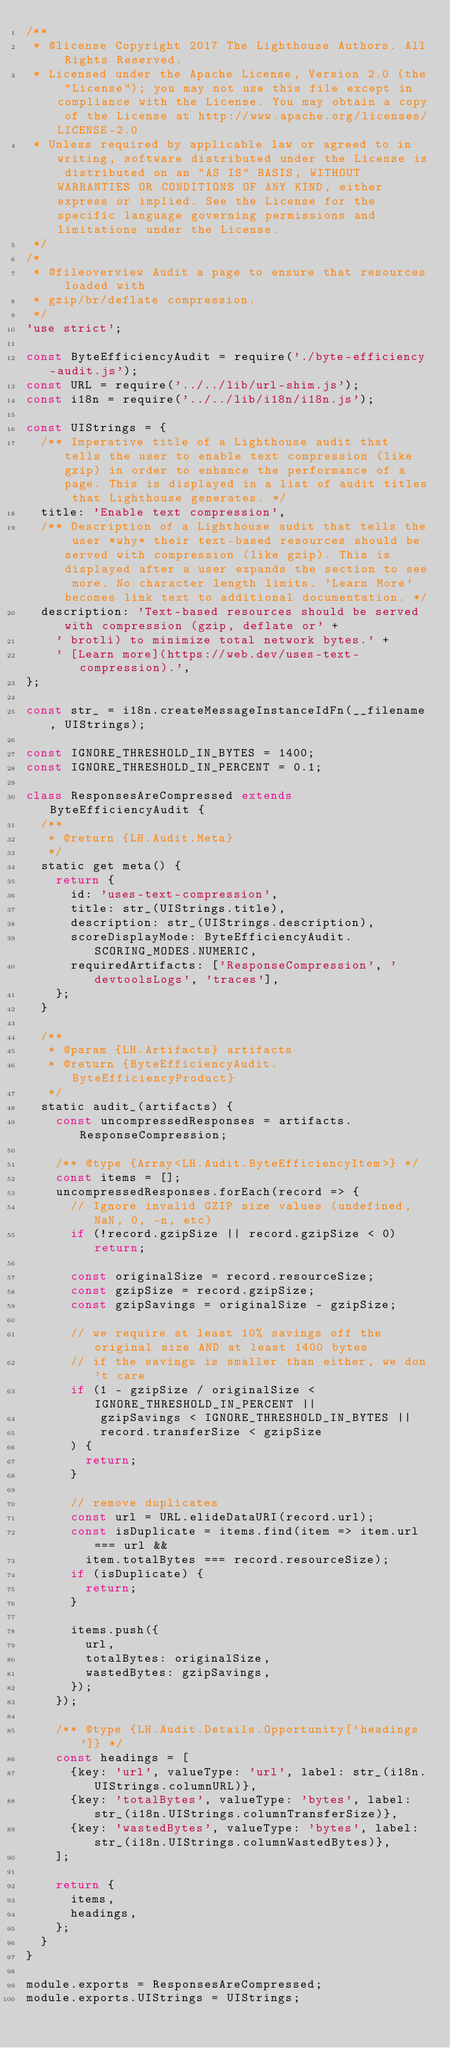Convert code to text. <code><loc_0><loc_0><loc_500><loc_500><_JavaScript_>/**
 * @license Copyright 2017 The Lighthouse Authors. All Rights Reserved.
 * Licensed under the Apache License, Version 2.0 (the "License"); you may not use this file except in compliance with the License. You may obtain a copy of the License at http://www.apache.org/licenses/LICENSE-2.0
 * Unless required by applicable law or agreed to in writing, software distributed under the License is distributed on an "AS IS" BASIS, WITHOUT WARRANTIES OR CONDITIONS OF ANY KIND, either express or implied. See the License for the specific language governing permissions and limitations under the License.
 */
/*
 * @fileoverview Audit a page to ensure that resources loaded with
 * gzip/br/deflate compression.
 */
'use strict';

const ByteEfficiencyAudit = require('./byte-efficiency-audit.js');
const URL = require('../../lib/url-shim.js');
const i18n = require('../../lib/i18n/i18n.js');

const UIStrings = {
  /** Imperative title of a Lighthouse audit that tells the user to enable text compression (like gzip) in order to enhance the performance of a page. This is displayed in a list of audit titles that Lighthouse generates. */
  title: 'Enable text compression',
  /** Description of a Lighthouse audit that tells the user *why* their text-based resources should be served with compression (like gzip). This is displayed after a user expands the section to see more. No character length limits. 'Learn More' becomes link text to additional documentation. */
  description: 'Text-based resources should be served with compression (gzip, deflate or' +
    ' brotli) to minimize total network bytes.' +
    ' [Learn more](https://web.dev/uses-text-compression).',
};

const str_ = i18n.createMessageInstanceIdFn(__filename, UIStrings);

const IGNORE_THRESHOLD_IN_BYTES = 1400;
const IGNORE_THRESHOLD_IN_PERCENT = 0.1;

class ResponsesAreCompressed extends ByteEfficiencyAudit {
  /**
   * @return {LH.Audit.Meta}
   */
  static get meta() {
    return {
      id: 'uses-text-compression',
      title: str_(UIStrings.title),
      description: str_(UIStrings.description),
      scoreDisplayMode: ByteEfficiencyAudit.SCORING_MODES.NUMERIC,
      requiredArtifacts: ['ResponseCompression', 'devtoolsLogs', 'traces'],
    };
  }

  /**
   * @param {LH.Artifacts} artifacts
   * @return {ByteEfficiencyAudit.ByteEfficiencyProduct}
   */
  static audit_(artifacts) {
    const uncompressedResponses = artifacts.ResponseCompression;

    /** @type {Array<LH.Audit.ByteEfficiencyItem>} */
    const items = [];
    uncompressedResponses.forEach(record => {
      // Ignore invalid GZIP size values (undefined, NaN, 0, -n, etc)
      if (!record.gzipSize || record.gzipSize < 0) return;

      const originalSize = record.resourceSize;
      const gzipSize = record.gzipSize;
      const gzipSavings = originalSize - gzipSize;

      // we require at least 10% savings off the original size AND at least 1400 bytes
      // if the savings is smaller than either, we don't care
      if (1 - gzipSize / originalSize < IGNORE_THRESHOLD_IN_PERCENT ||
          gzipSavings < IGNORE_THRESHOLD_IN_BYTES ||
          record.transferSize < gzipSize
      ) {
        return;
      }

      // remove duplicates
      const url = URL.elideDataURI(record.url);
      const isDuplicate = items.find(item => item.url === url &&
        item.totalBytes === record.resourceSize);
      if (isDuplicate) {
        return;
      }

      items.push({
        url,
        totalBytes: originalSize,
        wastedBytes: gzipSavings,
      });
    });

    /** @type {LH.Audit.Details.Opportunity['headings']} */
    const headings = [
      {key: 'url', valueType: 'url', label: str_(i18n.UIStrings.columnURL)},
      {key: 'totalBytes', valueType: 'bytes', label: str_(i18n.UIStrings.columnTransferSize)},
      {key: 'wastedBytes', valueType: 'bytes', label: str_(i18n.UIStrings.columnWastedBytes)},
    ];

    return {
      items,
      headings,
    };
  }
}

module.exports = ResponsesAreCompressed;
module.exports.UIStrings = UIStrings;
</code> 